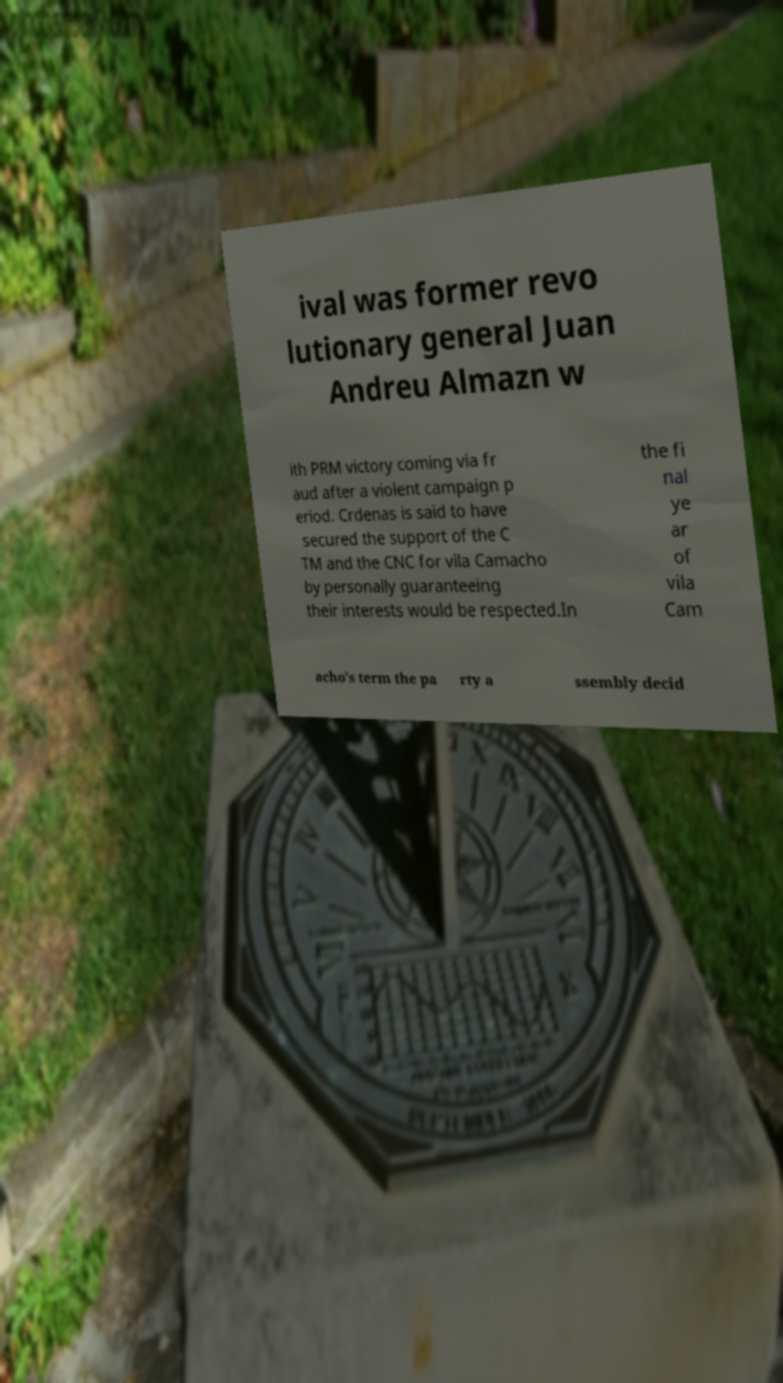I need the written content from this picture converted into text. Can you do that? ival was former revo lutionary general Juan Andreu Almazn w ith PRM victory coming via fr aud after a violent campaign p eriod. Crdenas is said to have secured the support of the C TM and the CNC for vila Camacho by personally guaranteeing their interests would be respected.In the fi nal ye ar of vila Cam acho's term the pa rty a ssembly decid 